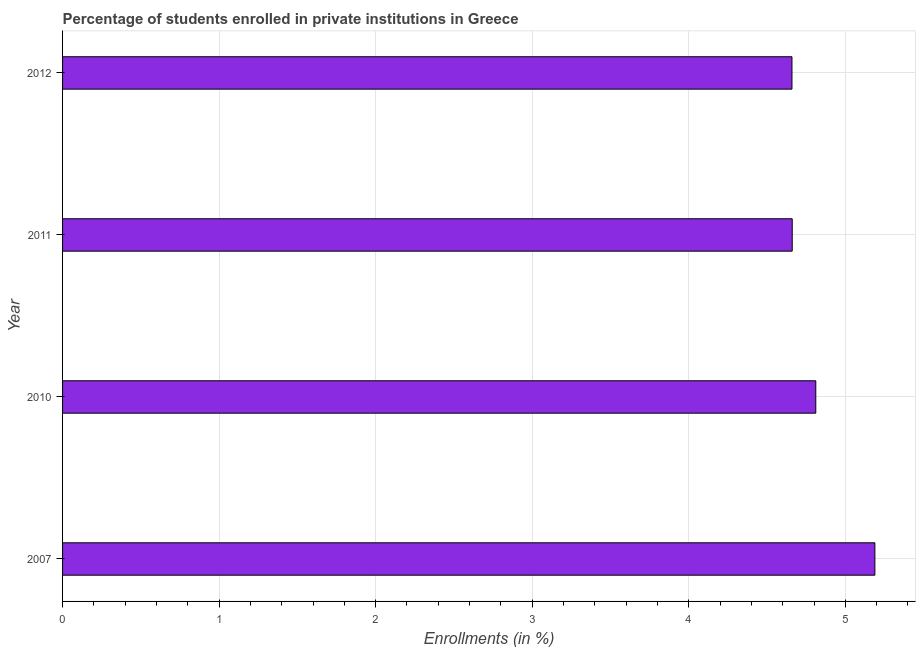Does the graph contain grids?
Provide a short and direct response. Yes. What is the title of the graph?
Ensure brevity in your answer.  Percentage of students enrolled in private institutions in Greece. What is the label or title of the X-axis?
Ensure brevity in your answer.  Enrollments (in %). What is the label or title of the Y-axis?
Offer a very short reply. Year. What is the enrollments in private institutions in 2007?
Make the answer very short. 5.19. Across all years, what is the maximum enrollments in private institutions?
Ensure brevity in your answer.  5.19. Across all years, what is the minimum enrollments in private institutions?
Ensure brevity in your answer.  4.66. What is the sum of the enrollments in private institutions?
Provide a succinct answer. 19.32. What is the difference between the enrollments in private institutions in 2010 and 2011?
Give a very brief answer. 0.15. What is the average enrollments in private institutions per year?
Your answer should be compact. 4.83. What is the median enrollments in private institutions?
Ensure brevity in your answer.  4.74. Do a majority of the years between 2010 and 2007 (inclusive) have enrollments in private institutions greater than 4.6 %?
Provide a succinct answer. No. What is the ratio of the enrollments in private institutions in 2010 to that in 2012?
Your answer should be very brief. 1.03. Is the difference between the enrollments in private institutions in 2010 and 2012 greater than the difference between any two years?
Your answer should be very brief. No. What is the difference between the highest and the second highest enrollments in private institutions?
Offer a terse response. 0.38. Is the sum of the enrollments in private institutions in 2007 and 2010 greater than the maximum enrollments in private institutions across all years?
Provide a short and direct response. Yes. What is the difference between the highest and the lowest enrollments in private institutions?
Give a very brief answer. 0.53. In how many years, is the enrollments in private institutions greater than the average enrollments in private institutions taken over all years?
Offer a terse response. 1. Are all the bars in the graph horizontal?
Give a very brief answer. Yes. Are the values on the major ticks of X-axis written in scientific E-notation?
Keep it short and to the point. No. What is the Enrollments (in %) of 2007?
Your answer should be very brief. 5.19. What is the Enrollments (in %) in 2010?
Make the answer very short. 4.81. What is the Enrollments (in %) of 2011?
Your answer should be very brief. 4.66. What is the Enrollments (in %) of 2012?
Provide a succinct answer. 4.66. What is the difference between the Enrollments (in %) in 2007 and 2010?
Provide a succinct answer. 0.38. What is the difference between the Enrollments (in %) in 2007 and 2011?
Your answer should be very brief. 0.53. What is the difference between the Enrollments (in %) in 2007 and 2012?
Provide a short and direct response. 0.53. What is the difference between the Enrollments (in %) in 2010 and 2011?
Give a very brief answer. 0.15. What is the difference between the Enrollments (in %) in 2010 and 2012?
Your response must be concise. 0.15. What is the difference between the Enrollments (in %) in 2011 and 2012?
Give a very brief answer. 0. What is the ratio of the Enrollments (in %) in 2007 to that in 2010?
Provide a short and direct response. 1.08. What is the ratio of the Enrollments (in %) in 2007 to that in 2011?
Provide a short and direct response. 1.11. What is the ratio of the Enrollments (in %) in 2007 to that in 2012?
Provide a short and direct response. 1.11. What is the ratio of the Enrollments (in %) in 2010 to that in 2011?
Provide a succinct answer. 1.03. What is the ratio of the Enrollments (in %) in 2010 to that in 2012?
Give a very brief answer. 1.03. 